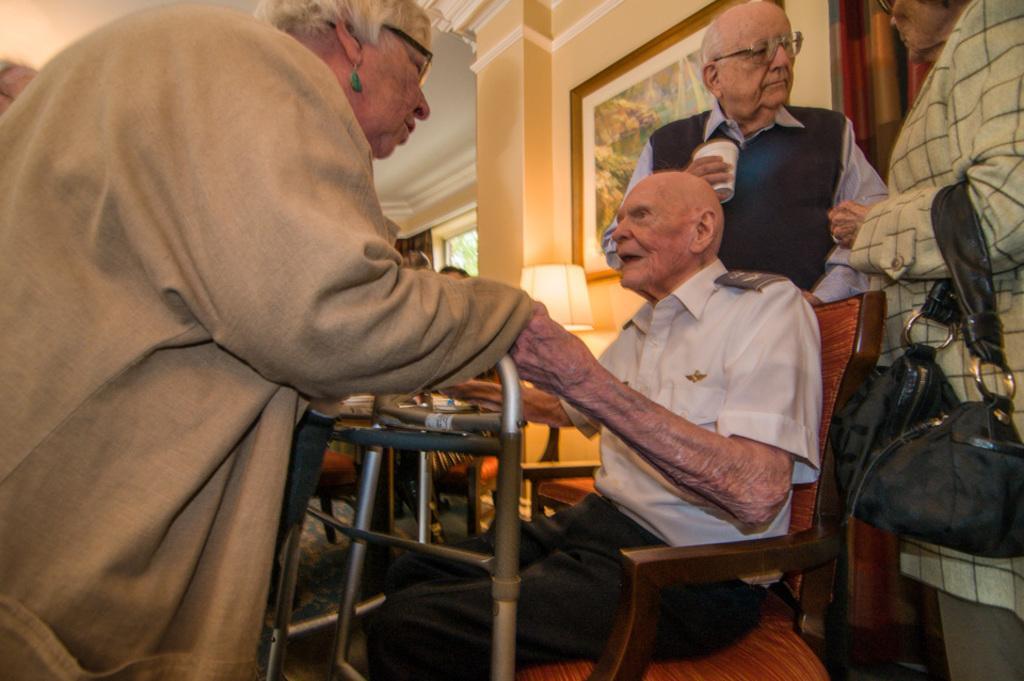Describe this image in one or two sentences. On the left side, there is a person in a brown color jacket, holding a hand of a person who is in white color shirt and is sitting on a wooden chair. In front of this person, there is a stand. On the right side, there is a person holding a handbag and standing. In the background, there is a person holding a white color glass, there is a photo frame attached to the wall, there is a light, a window and there are other objects. 